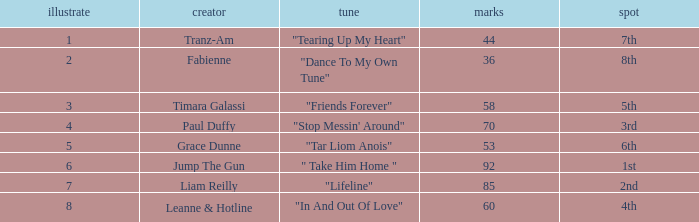What's the song of artist liam reilly? "Lifeline". 